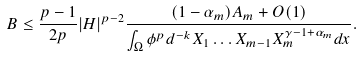<formula> <loc_0><loc_0><loc_500><loc_500>B \leq \frac { p - 1 } { 2 p } | H | ^ { p - 2 } \frac { ( 1 - \alpha _ { m } ) A _ { m } + O ( 1 ) } { \int _ { \Omega } \phi ^ { p } d ^ { - k } X _ { 1 } \dots X _ { m - 1 } X _ { m } ^ { \gamma - 1 + \alpha _ { m } } d x } .</formula> 